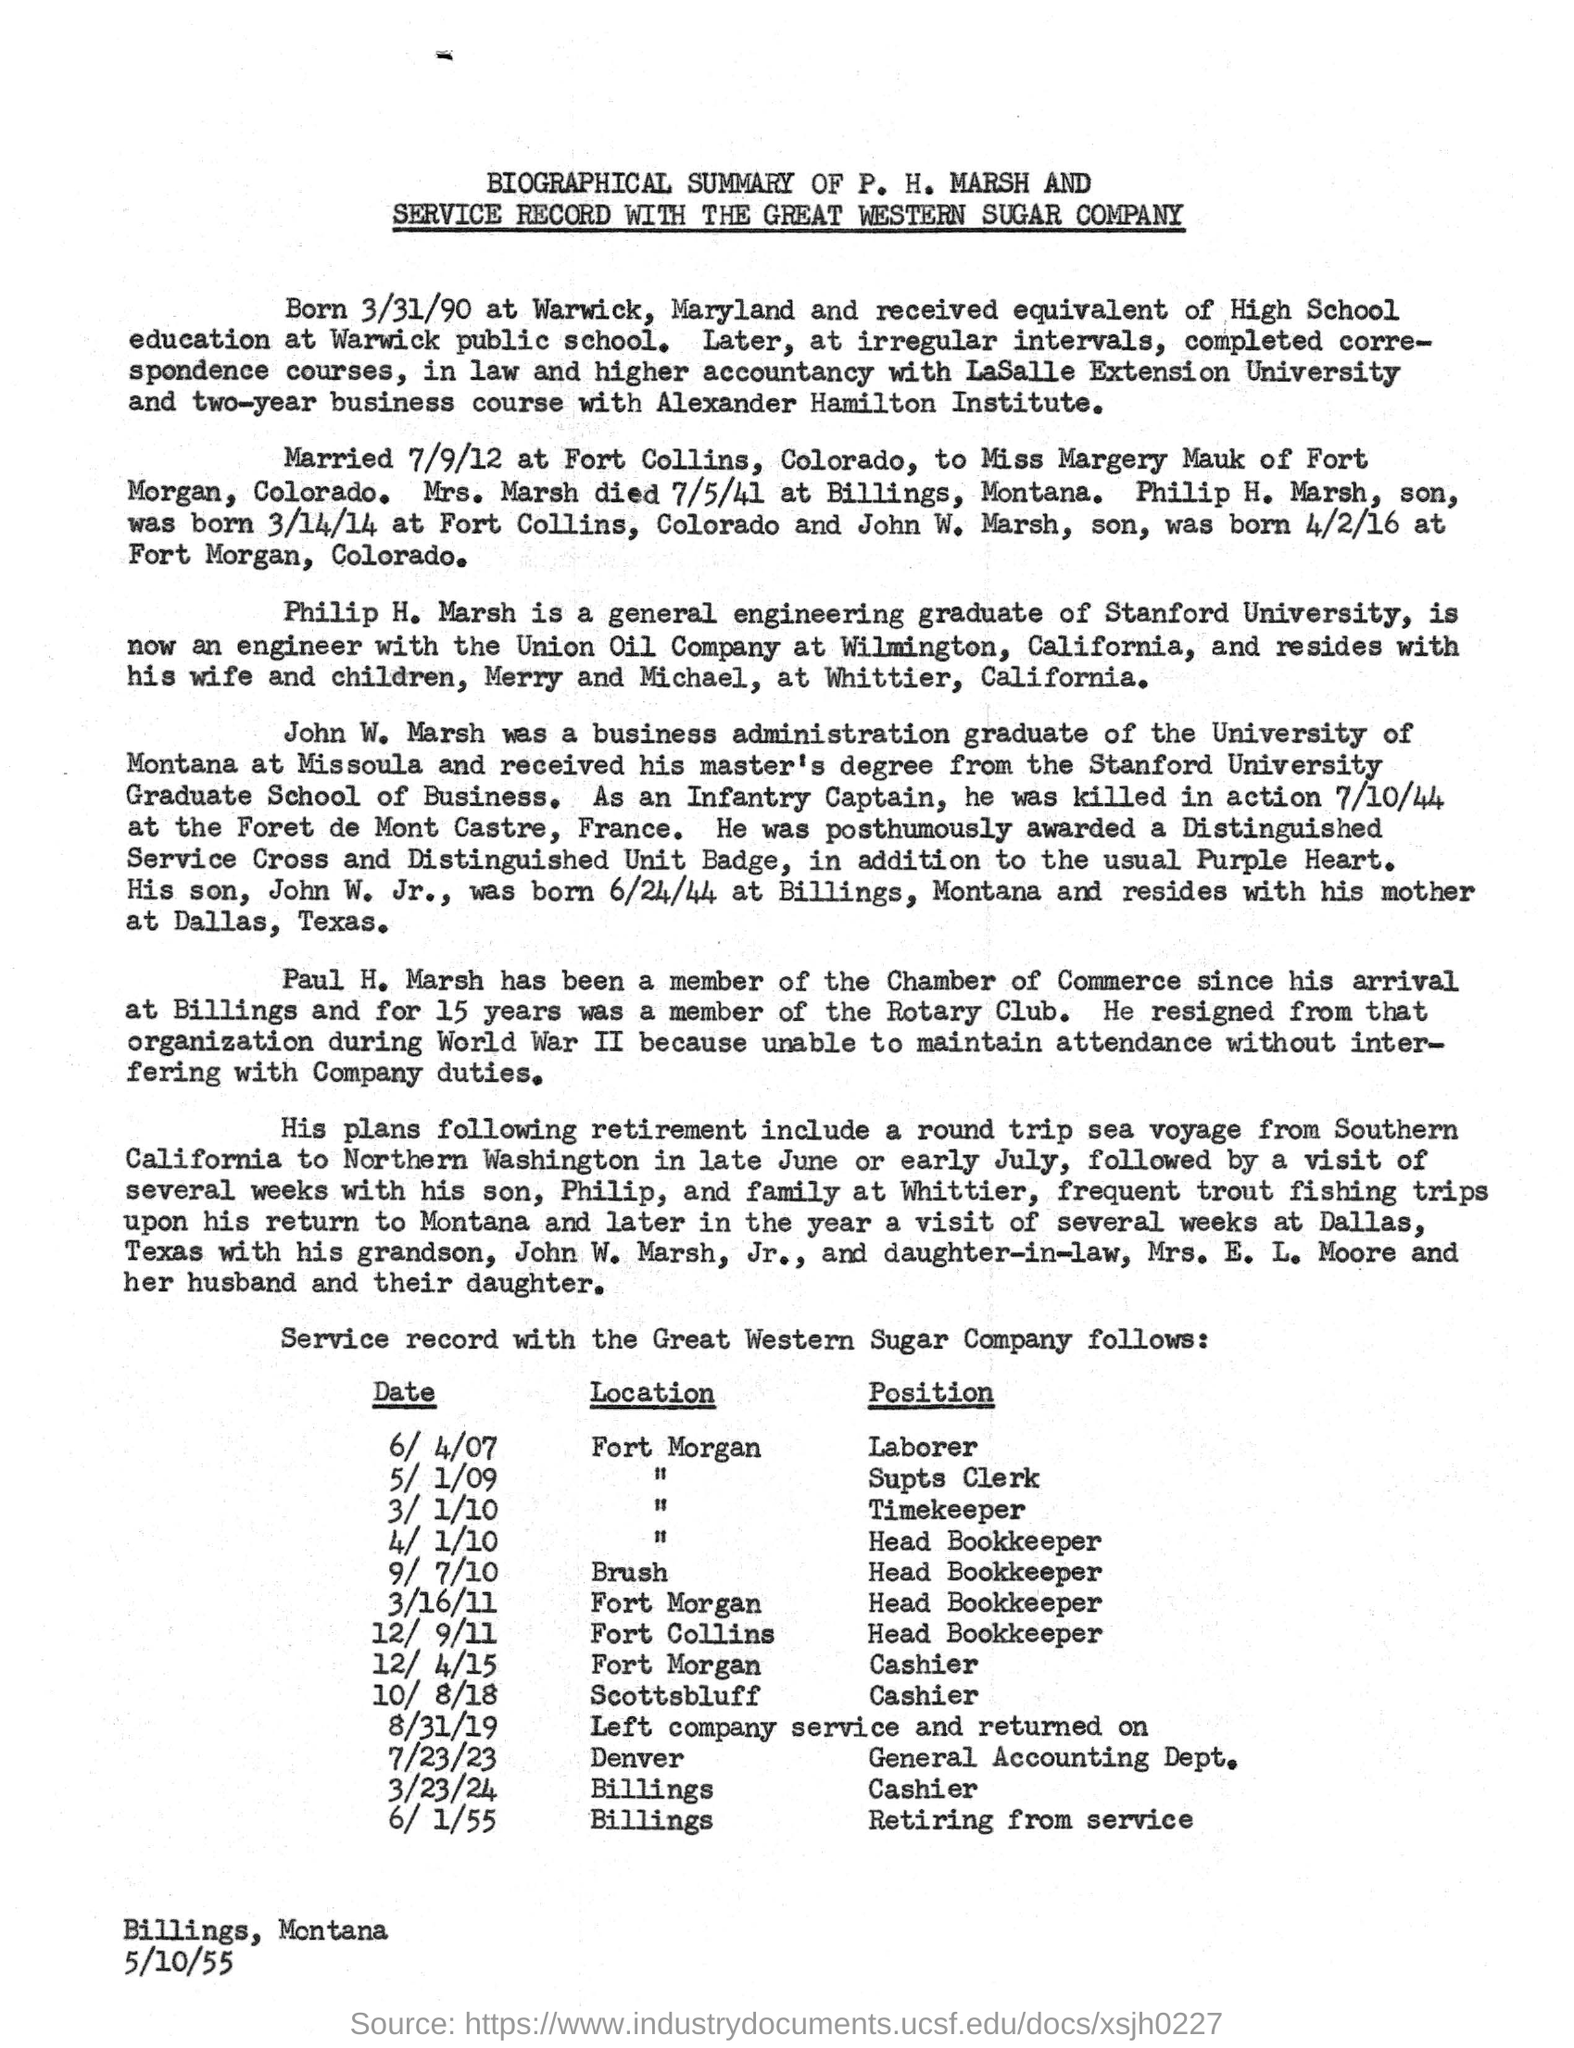Mention a couple of crucial points in this snapshot. The document is dated May 10th, 1955. P.H. MARSH is married to Miss Margery Mauk of Fort Morgan, Colorado. 